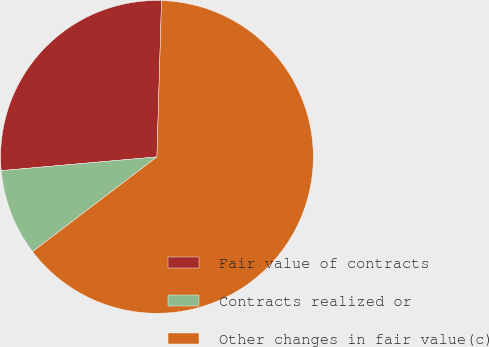Convert chart to OTSL. <chart><loc_0><loc_0><loc_500><loc_500><pie_chart><fcel>Fair value of contracts<fcel>Contracts realized or<fcel>Other changes in fair value(c)<nl><fcel>26.87%<fcel>8.96%<fcel>64.18%<nl></chart> 